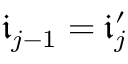Convert formula to latex. <formula><loc_0><loc_0><loc_500><loc_500>\mathfrak { i } _ { j - 1 } = \mathfrak { i } _ { j } ^ { \prime }</formula> 